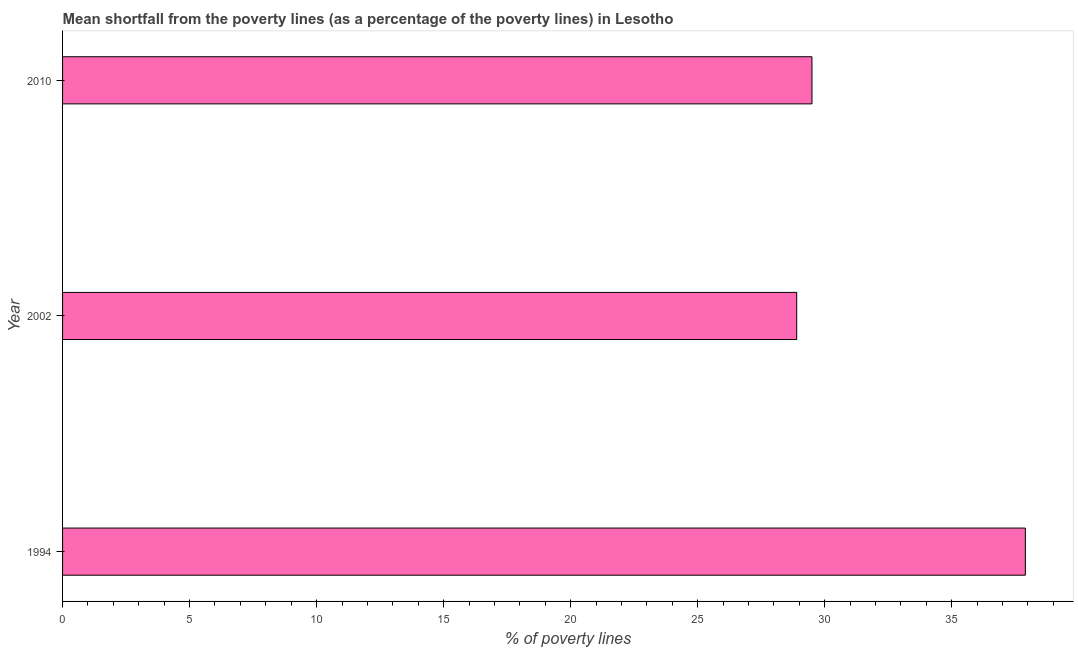What is the title of the graph?
Your response must be concise. Mean shortfall from the poverty lines (as a percentage of the poverty lines) in Lesotho. What is the label or title of the X-axis?
Offer a very short reply. % of poverty lines. What is the poverty gap at national poverty lines in 1994?
Make the answer very short. 37.9. Across all years, what is the maximum poverty gap at national poverty lines?
Offer a very short reply. 37.9. Across all years, what is the minimum poverty gap at national poverty lines?
Offer a terse response. 28.9. In which year was the poverty gap at national poverty lines maximum?
Ensure brevity in your answer.  1994. What is the sum of the poverty gap at national poverty lines?
Your answer should be very brief. 96.3. What is the average poverty gap at national poverty lines per year?
Ensure brevity in your answer.  32.1. What is the median poverty gap at national poverty lines?
Provide a succinct answer. 29.5. Do a majority of the years between 2002 and 2010 (inclusive) have poverty gap at national poverty lines greater than 9 %?
Offer a very short reply. Yes. What is the ratio of the poverty gap at national poverty lines in 1994 to that in 2002?
Give a very brief answer. 1.31. What is the difference between the highest and the second highest poverty gap at national poverty lines?
Offer a very short reply. 8.4. How many years are there in the graph?
Your response must be concise. 3. Are the values on the major ticks of X-axis written in scientific E-notation?
Offer a terse response. No. What is the % of poverty lines in 1994?
Give a very brief answer. 37.9. What is the % of poverty lines in 2002?
Give a very brief answer. 28.9. What is the % of poverty lines of 2010?
Give a very brief answer. 29.5. What is the difference between the % of poverty lines in 1994 and 2002?
Keep it short and to the point. 9. What is the difference between the % of poverty lines in 2002 and 2010?
Give a very brief answer. -0.6. What is the ratio of the % of poverty lines in 1994 to that in 2002?
Your answer should be very brief. 1.31. What is the ratio of the % of poverty lines in 1994 to that in 2010?
Make the answer very short. 1.28. What is the ratio of the % of poverty lines in 2002 to that in 2010?
Make the answer very short. 0.98. 